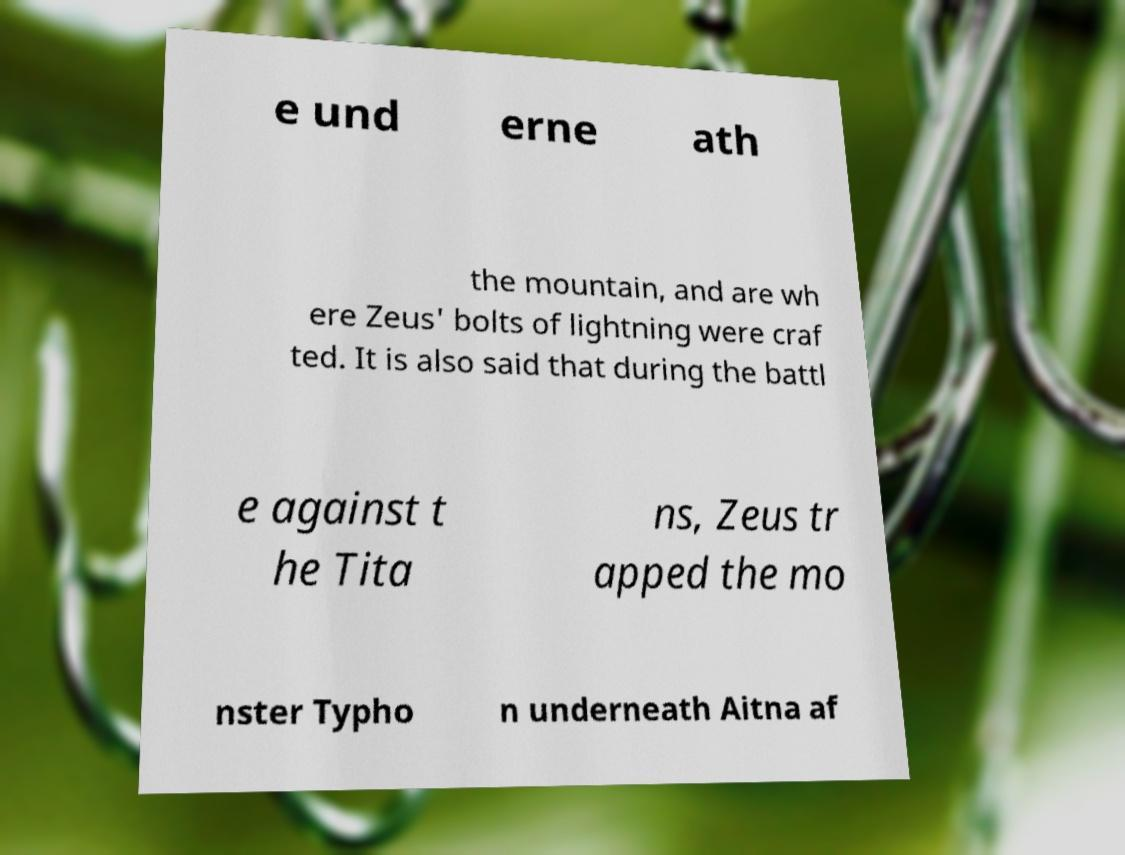Can you accurately transcribe the text from the provided image for me? e und erne ath the mountain, and are wh ere Zeus' bolts of lightning were craf ted. It is also said that during the battl e against t he Tita ns, Zeus tr apped the mo nster Typho n underneath Aitna af 